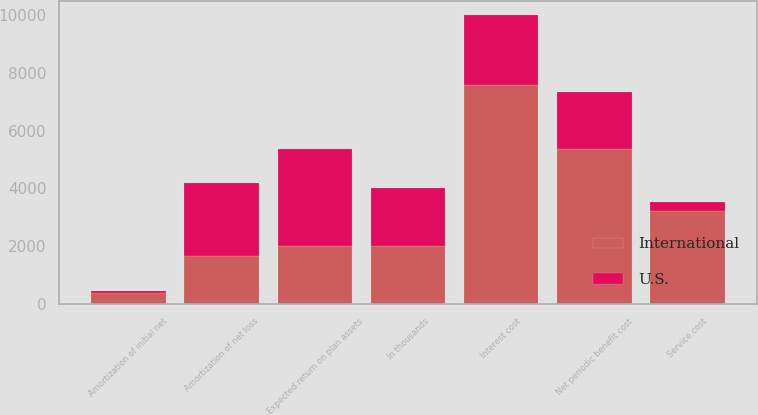Convert chart to OTSL. <chart><loc_0><loc_0><loc_500><loc_500><stacked_bar_chart><ecel><fcel>In thousands<fcel>Service cost<fcel>Interest cost<fcel>Expected return on plan assets<fcel>Amortization of initial net<fcel>Amortization of net loss<fcel>Net periodic benefit cost<nl><fcel>U.S.<fcel>2011<fcel>309<fcel>2428<fcel>3331<fcel>62<fcel>2502<fcel>1970<nl><fcel>International<fcel>2011<fcel>3204<fcel>7575<fcel>2011<fcel>380<fcel>1665<fcel>5371<nl></chart> 